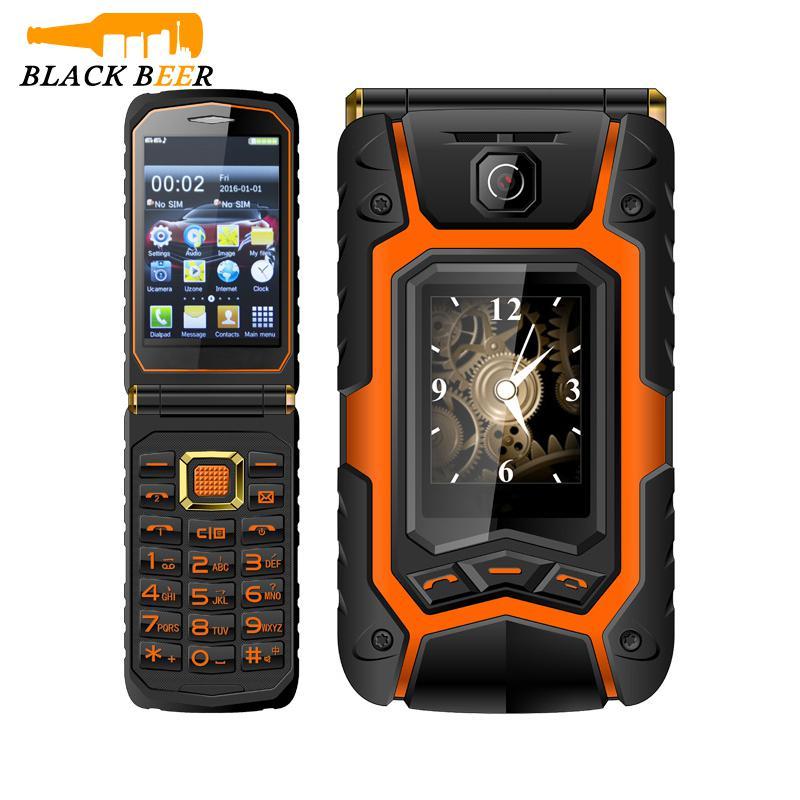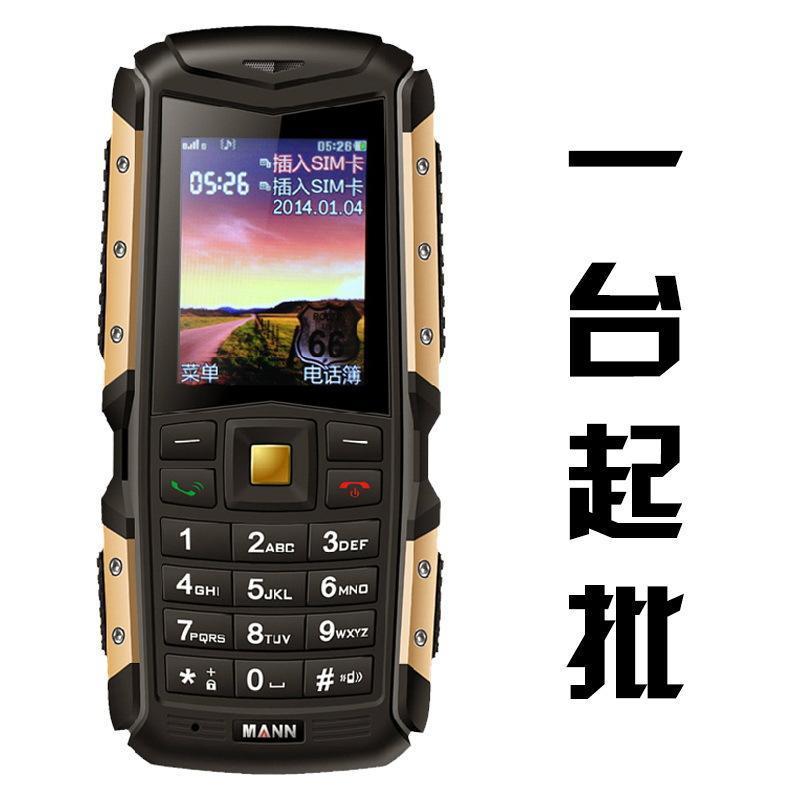The first image is the image on the left, the second image is the image on the right. For the images shown, is this caption "Both of the images are showing two different views of the same cell phone." true? Answer yes or no. No. The first image is the image on the left, the second image is the image on the right. Assess this claim about the two images: "The back of a phone is visible.". Correct or not? Answer yes or no. No. 